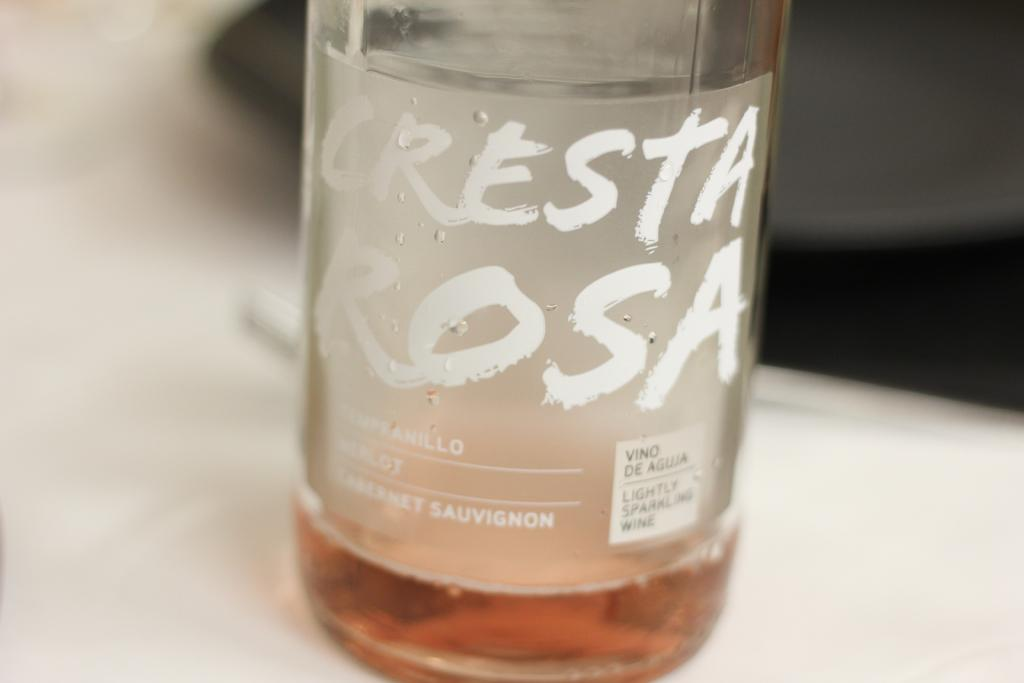What object is present in the image that has a name on it? There is a bottle in the image, and it has the name "Cresta Rosa" on it. Where is the bottle located in the image? The bottle is on a table in the image. Can you see a giraffe standing next to the bottle in the image? No, there is no giraffe present in the image. What type of hook is used to hang the bottle in the image? There is no hook used to hang the bottle in the image, as it is sitting on a table. 